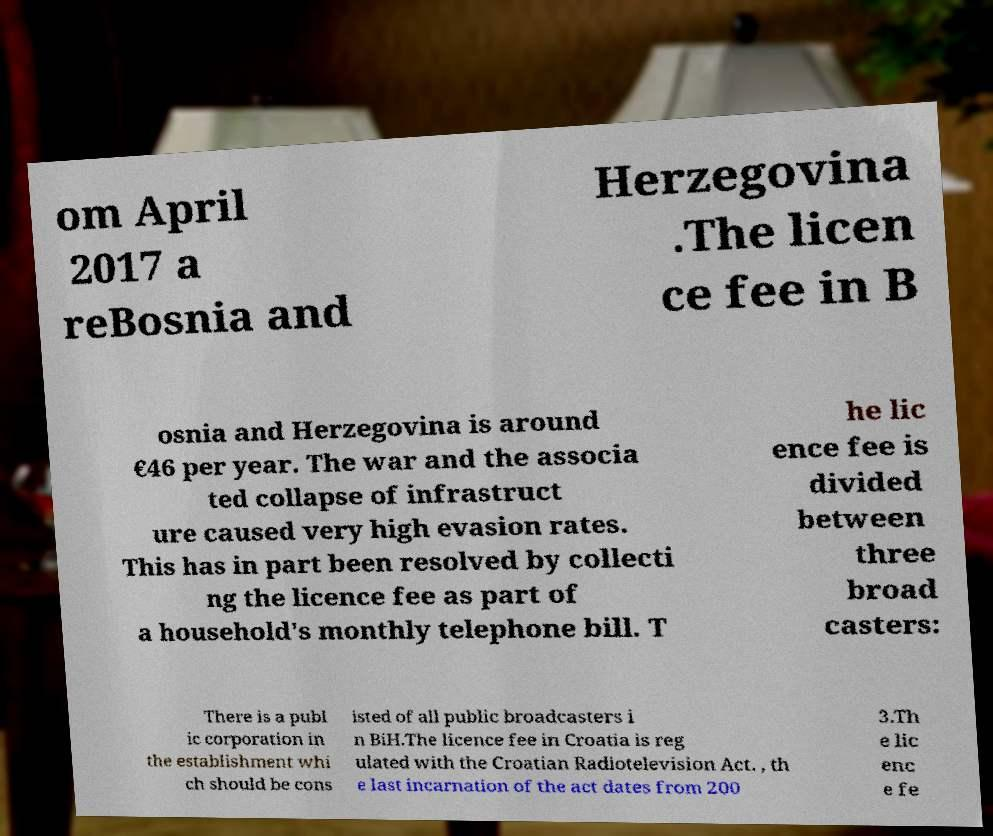Could you assist in decoding the text presented in this image and type it out clearly? om April 2017 a reBosnia and Herzegovina .The licen ce fee in B osnia and Herzegovina is around €46 per year. The war and the associa ted collapse of infrastruct ure caused very high evasion rates. This has in part been resolved by collecti ng the licence fee as part of a household's monthly telephone bill. T he lic ence fee is divided between three broad casters: There is a publ ic corporation in the establishment whi ch should be cons isted of all public broadcasters i n BiH.The licence fee in Croatia is reg ulated with the Croatian Radiotelevision Act. , th e last incarnation of the act dates from 200 3.Th e lic enc e fe 